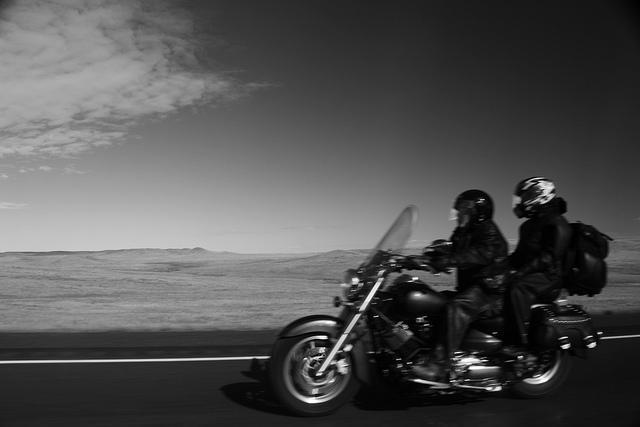How many people are there?
Give a very brief answer. 2. 